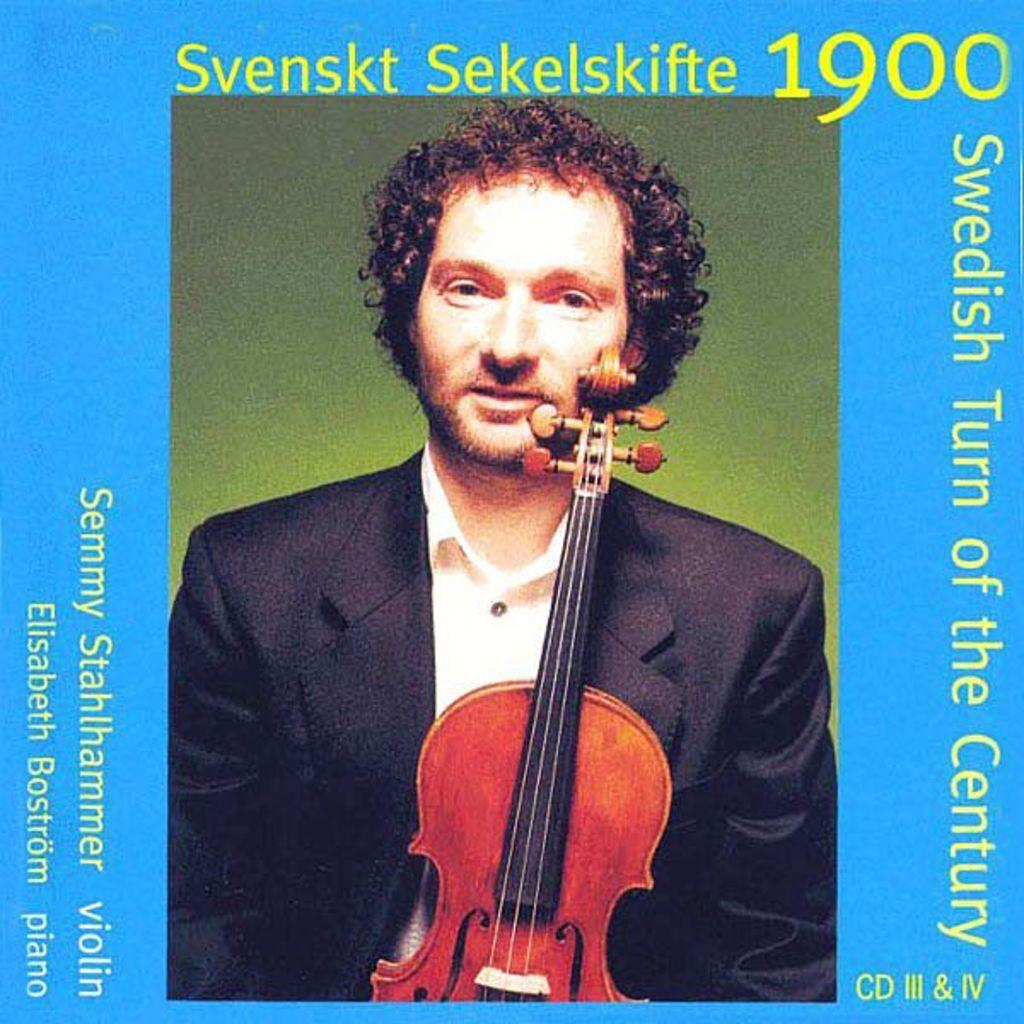What is present on the poster in the image? There is a poster in the image. What can be seen on the poster besides text? The poster contains images. What type of information is present on the poster? The poster contains text. What direction is the thumb pointing on the poster in the image? There is no thumb present on the poster in the image. What type of material is the leather used for on the poster in the image? There is no leather present on the poster in the image. 